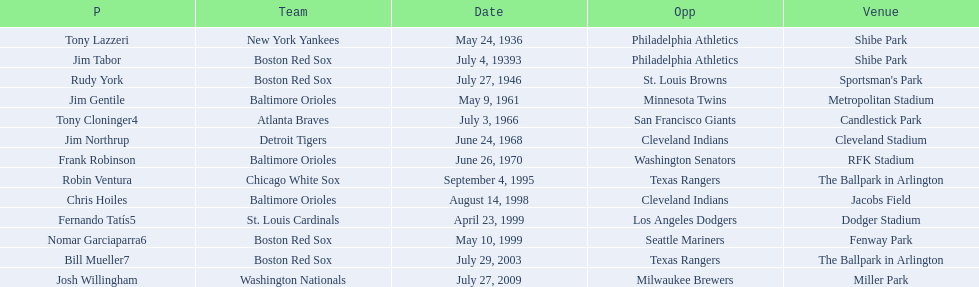Which teams played between the years 1960 and 1970? Baltimore Orioles, Atlanta Braves, Detroit Tigers, Baltimore Orioles. Of these teams that played, which ones played against the cleveland indians? Detroit Tigers. On what day did these two teams play? June 24, 1968. 